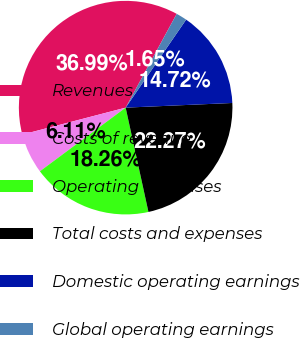Convert chart. <chart><loc_0><loc_0><loc_500><loc_500><pie_chart><fcel>Revenues<fcel>Costs of revenue<fcel>Operating expenses<fcel>Total costs and expenses<fcel>Domestic operating earnings<fcel>Global operating earnings<nl><fcel>36.99%<fcel>6.11%<fcel>18.26%<fcel>22.27%<fcel>14.72%<fcel>1.65%<nl></chart> 